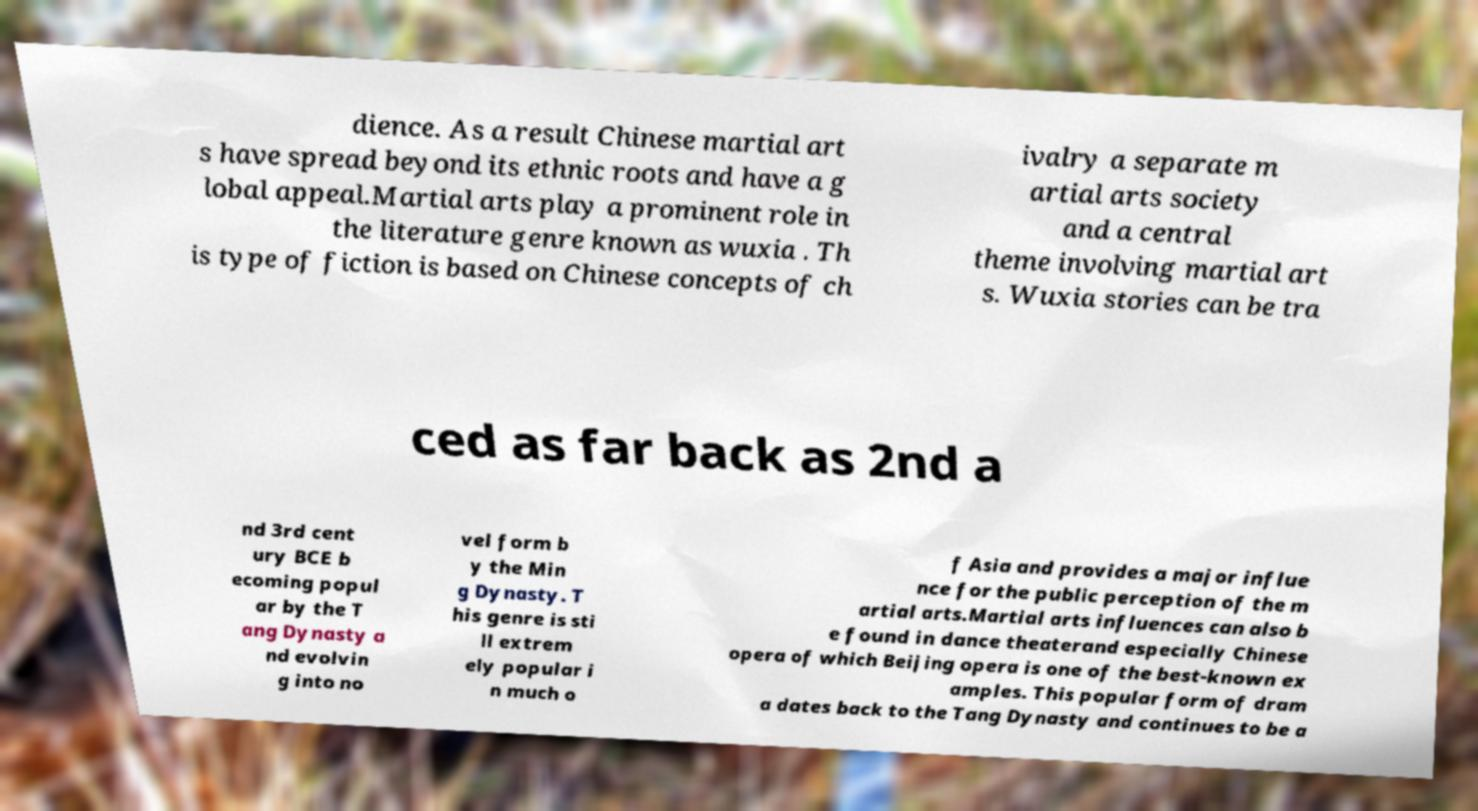There's text embedded in this image that I need extracted. Can you transcribe it verbatim? dience. As a result Chinese martial art s have spread beyond its ethnic roots and have a g lobal appeal.Martial arts play a prominent role in the literature genre known as wuxia . Th is type of fiction is based on Chinese concepts of ch ivalry a separate m artial arts society and a central theme involving martial art s. Wuxia stories can be tra ced as far back as 2nd a nd 3rd cent ury BCE b ecoming popul ar by the T ang Dynasty a nd evolvin g into no vel form b y the Min g Dynasty. T his genre is sti ll extrem ely popular i n much o f Asia and provides a major influe nce for the public perception of the m artial arts.Martial arts influences can also b e found in dance theaterand especially Chinese opera of which Beijing opera is one of the best-known ex amples. This popular form of dram a dates back to the Tang Dynasty and continues to be a 